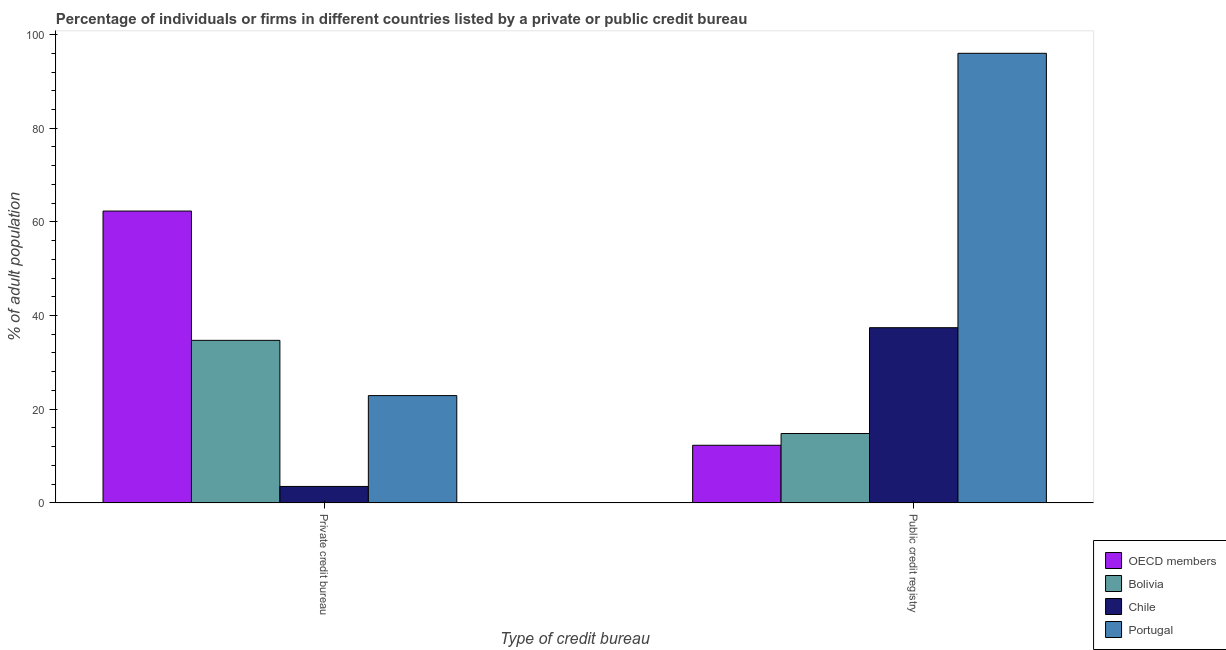How many different coloured bars are there?
Your answer should be very brief. 4. How many groups of bars are there?
Ensure brevity in your answer.  2. Are the number of bars per tick equal to the number of legend labels?
Provide a succinct answer. Yes. Are the number of bars on each tick of the X-axis equal?
Your response must be concise. Yes. How many bars are there on the 1st tick from the left?
Make the answer very short. 4. How many bars are there on the 1st tick from the right?
Offer a very short reply. 4. What is the label of the 2nd group of bars from the left?
Offer a terse response. Public credit registry. What is the percentage of firms listed by private credit bureau in Chile?
Provide a succinct answer. 3.5. Across all countries, what is the maximum percentage of firms listed by public credit bureau?
Provide a short and direct response. 96. Across all countries, what is the minimum percentage of firms listed by public credit bureau?
Offer a very short reply. 12.29. In which country was the percentage of firms listed by private credit bureau maximum?
Your answer should be very brief. OECD members. What is the total percentage of firms listed by private credit bureau in the graph?
Ensure brevity in your answer.  123.41. What is the difference between the percentage of firms listed by private credit bureau in OECD members and that in Bolivia?
Make the answer very short. 27.61. What is the average percentage of firms listed by private credit bureau per country?
Your answer should be very brief. 30.85. What is the difference between the percentage of firms listed by public credit bureau and percentage of firms listed by private credit bureau in OECD members?
Give a very brief answer. -50.02. In how many countries, is the percentage of firms listed by private credit bureau greater than 36 %?
Your response must be concise. 1. What is the ratio of the percentage of firms listed by private credit bureau in OECD members to that in Bolivia?
Provide a short and direct response. 1.8. Is the percentage of firms listed by public credit bureau in Bolivia less than that in Portugal?
Your answer should be very brief. Yes. What does the 3rd bar from the left in Public credit registry represents?
Provide a short and direct response. Chile. How many bars are there?
Your answer should be very brief. 8. How many countries are there in the graph?
Your answer should be compact. 4. Where does the legend appear in the graph?
Give a very brief answer. Bottom right. How many legend labels are there?
Give a very brief answer. 4. How are the legend labels stacked?
Your response must be concise. Vertical. What is the title of the graph?
Provide a short and direct response. Percentage of individuals or firms in different countries listed by a private or public credit bureau. Does "Samoa" appear as one of the legend labels in the graph?
Make the answer very short. No. What is the label or title of the X-axis?
Offer a very short reply. Type of credit bureau. What is the label or title of the Y-axis?
Your answer should be compact. % of adult population. What is the % of adult population of OECD members in Private credit bureau?
Your response must be concise. 62.31. What is the % of adult population in Bolivia in Private credit bureau?
Your answer should be compact. 34.7. What is the % of adult population in Chile in Private credit bureau?
Make the answer very short. 3.5. What is the % of adult population of Portugal in Private credit bureau?
Your response must be concise. 22.9. What is the % of adult population of OECD members in Public credit registry?
Give a very brief answer. 12.29. What is the % of adult population of Chile in Public credit registry?
Provide a succinct answer. 37.4. What is the % of adult population in Portugal in Public credit registry?
Offer a very short reply. 96. Across all Type of credit bureau, what is the maximum % of adult population in OECD members?
Offer a very short reply. 62.31. Across all Type of credit bureau, what is the maximum % of adult population of Bolivia?
Offer a very short reply. 34.7. Across all Type of credit bureau, what is the maximum % of adult population of Chile?
Your answer should be compact. 37.4. Across all Type of credit bureau, what is the maximum % of adult population of Portugal?
Offer a very short reply. 96. Across all Type of credit bureau, what is the minimum % of adult population of OECD members?
Make the answer very short. 12.29. Across all Type of credit bureau, what is the minimum % of adult population in Portugal?
Provide a succinct answer. 22.9. What is the total % of adult population of OECD members in the graph?
Your answer should be very brief. 74.6. What is the total % of adult population in Bolivia in the graph?
Provide a succinct answer. 49.5. What is the total % of adult population of Chile in the graph?
Keep it short and to the point. 40.9. What is the total % of adult population in Portugal in the graph?
Give a very brief answer. 118.9. What is the difference between the % of adult population in OECD members in Private credit bureau and that in Public credit registry?
Make the answer very short. 50.02. What is the difference between the % of adult population in Bolivia in Private credit bureau and that in Public credit registry?
Keep it short and to the point. 19.9. What is the difference between the % of adult population of Chile in Private credit bureau and that in Public credit registry?
Provide a short and direct response. -33.9. What is the difference between the % of adult population of Portugal in Private credit bureau and that in Public credit registry?
Make the answer very short. -73.1. What is the difference between the % of adult population of OECD members in Private credit bureau and the % of adult population of Bolivia in Public credit registry?
Offer a terse response. 47.51. What is the difference between the % of adult population in OECD members in Private credit bureau and the % of adult population in Chile in Public credit registry?
Offer a very short reply. 24.91. What is the difference between the % of adult population of OECD members in Private credit bureau and the % of adult population of Portugal in Public credit registry?
Your answer should be compact. -33.69. What is the difference between the % of adult population in Bolivia in Private credit bureau and the % of adult population in Portugal in Public credit registry?
Keep it short and to the point. -61.3. What is the difference between the % of adult population in Chile in Private credit bureau and the % of adult population in Portugal in Public credit registry?
Your answer should be very brief. -92.5. What is the average % of adult population in OECD members per Type of credit bureau?
Provide a short and direct response. 37.3. What is the average % of adult population in Bolivia per Type of credit bureau?
Your answer should be compact. 24.75. What is the average % of adult population in Chile per Type of credit bureau?
Offer a very short reply. 20.45. What is the average % of adult population in Portugal per Type of credit bureau?
Your response must be concise. 59.45. What is the difference between the % of adult population of OECD members and % of adult population of Bolivia in Private credit bureau?
Your answer should be very brief. 27.61. What is the difference between the % of adult population in OECD members and % of adult population in Chile in Private credit bureau?
Offer a terse response. 58.81. What is the difference between the % of adult population of OECD members and % of adult population of Portugal in Private credit bureau?
Provide a short and direct response. 39.41. What is the difference between the % of adult population of Bolivia and % of adult population of Chile in Private credit bureau?
Provide a succinct answer. 31.2. What is the difference between the % of adult population of Bolivia and % of adult population of Portugal in Private credit bureau?
Make the answer very short. 11.8. What is the difference between the % of adult population in Chile and % of adult population in Portugal in Private credit bureau?
Your response must be concise. -19.4. What is the difference between the % of adult population in OECD members and % of adult population in Bolivia in Public credit registry?
Provide a short and direct response. -2.51. What is the difference between the % of adult population of OECD members and % of adult population of Chile in Public credit registry?
Give a very brief answer. -25.11. What is the difference between the % of adult population of OECD members and % of adult population of Portugal in Public credit registry?
Offer a terse response. -83.71. What is the difference between the % of adult population of Bolivia and % of adult population of Chile in Public credit registry?
Offer a terse response. -22.6. What is the difference between the % of adult population in Bolivia and % of adult population in Portugal in Public credit registry?
Your answer should be very brief. -81.2. What is the difference between the % of adult population of Chile and % of adult population of Portugal in Public credit registry?
Your answer should be very brief. -58.6. What is the ratio of the % of adult population of OECD members in Private credit bureau to that in Public credit registry?
Your answer should be very brief. 5.07. What is the ratio of the % of adult population in Bolivia in Private credit bureau to that in Public credit registry?
Keep it short and to the point. 2.34. What is the ratio of the % of adult population in Chile in Private credit bureau to that in Public credit registry?
Ensure brevity in your answer.  0.09. What is the ratio of the % of adult population of Portugal in Private credit bureau to that in Public credit registry?
Your response must be concise. 0.24. What is the difference between the highest and the second highest % of adult population of OECD members?
Offer a very short reply. 50.02. What is the difference between the highest and the second highest % of adult population in Bolivia?
Ensure brevity in your answer.  19.9. What is the difference between the highest and the second highest % of adult population of Chile?
Make the answer very short. 33.9. What is the difference between the highest and the second highest % of adult population in Portugal?
Provide a short and direct response. 73.1. What is the difference between the highest and the lowest % of adult population of OECD members?
Offer a terse response. 50.02. What is the difference between the highest and the lowest % of adult population in Chile?
Provide a succinct answer. 33.9. What is the difference between the highest and the lowest % of adult population in Portugal?
Offer a terse response. 73.1. 